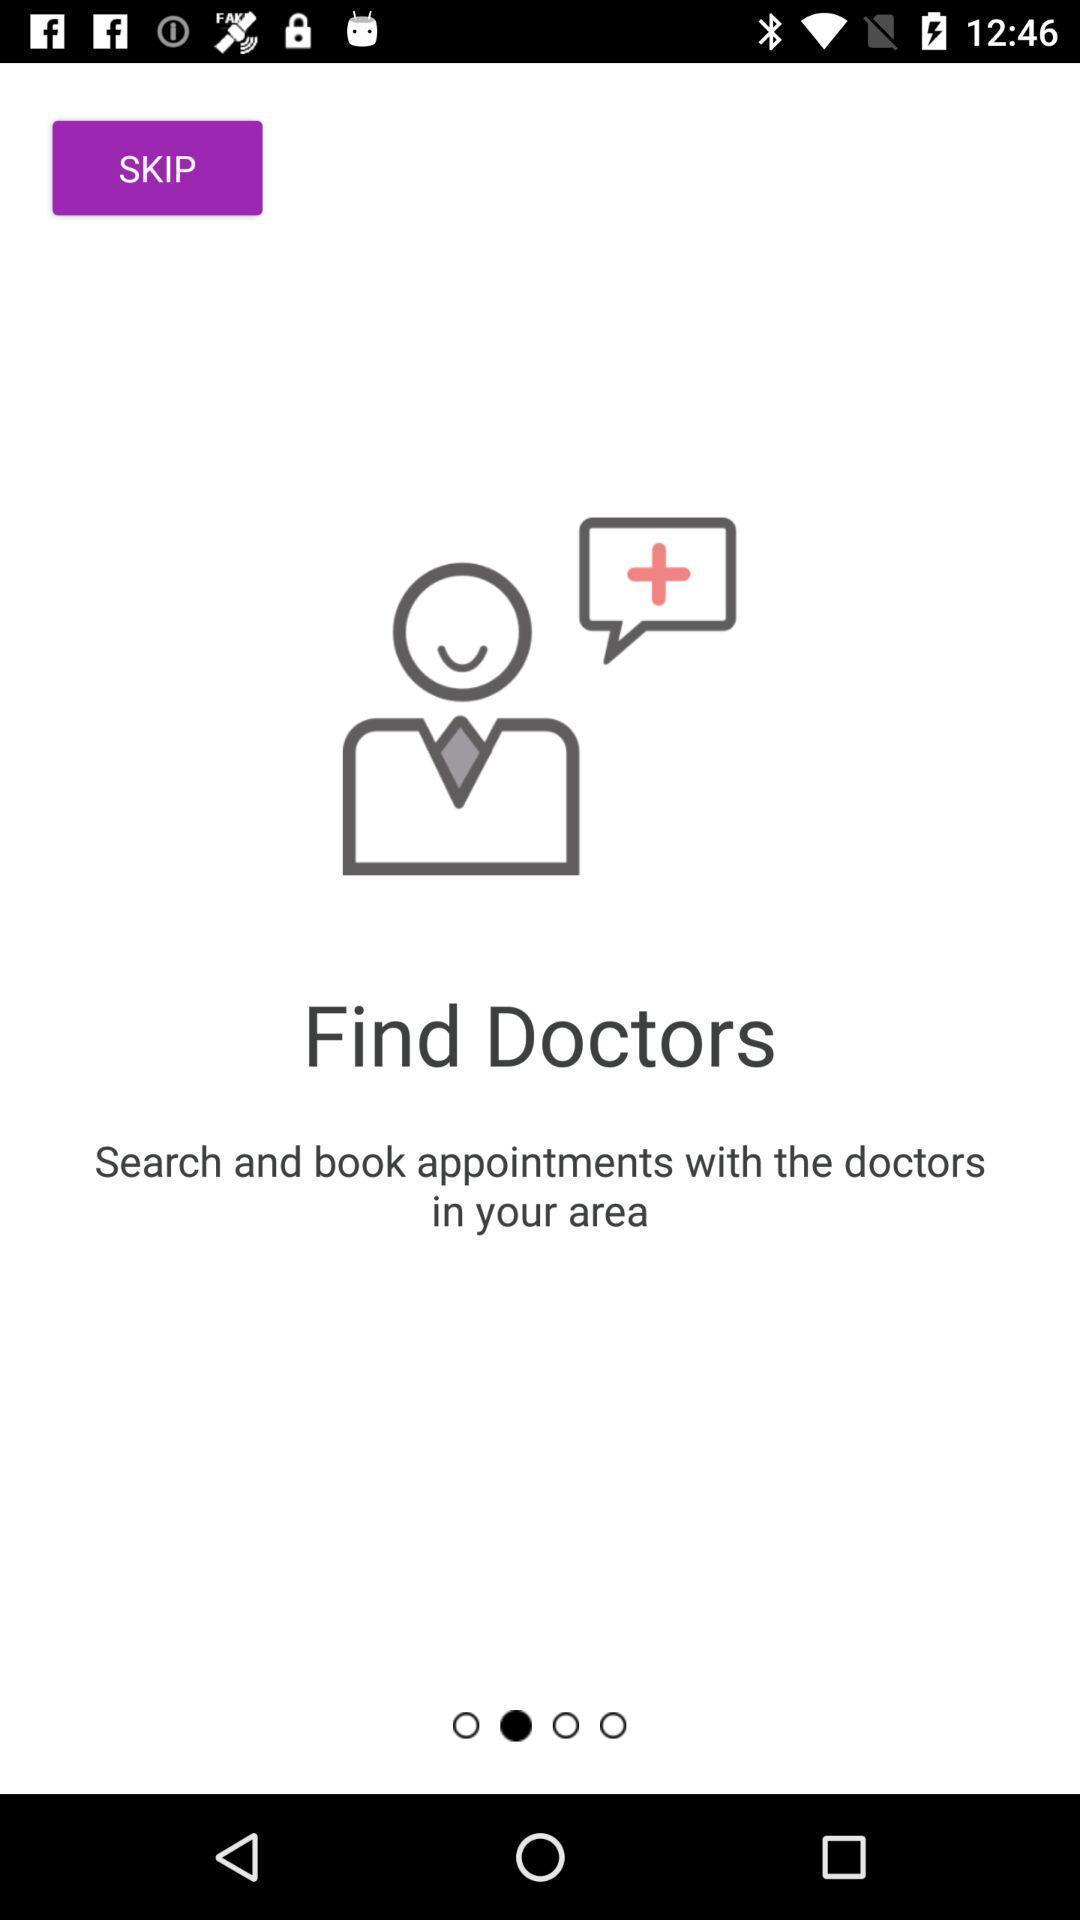Provide a description of this screenshot. Page for finding the doctors. 